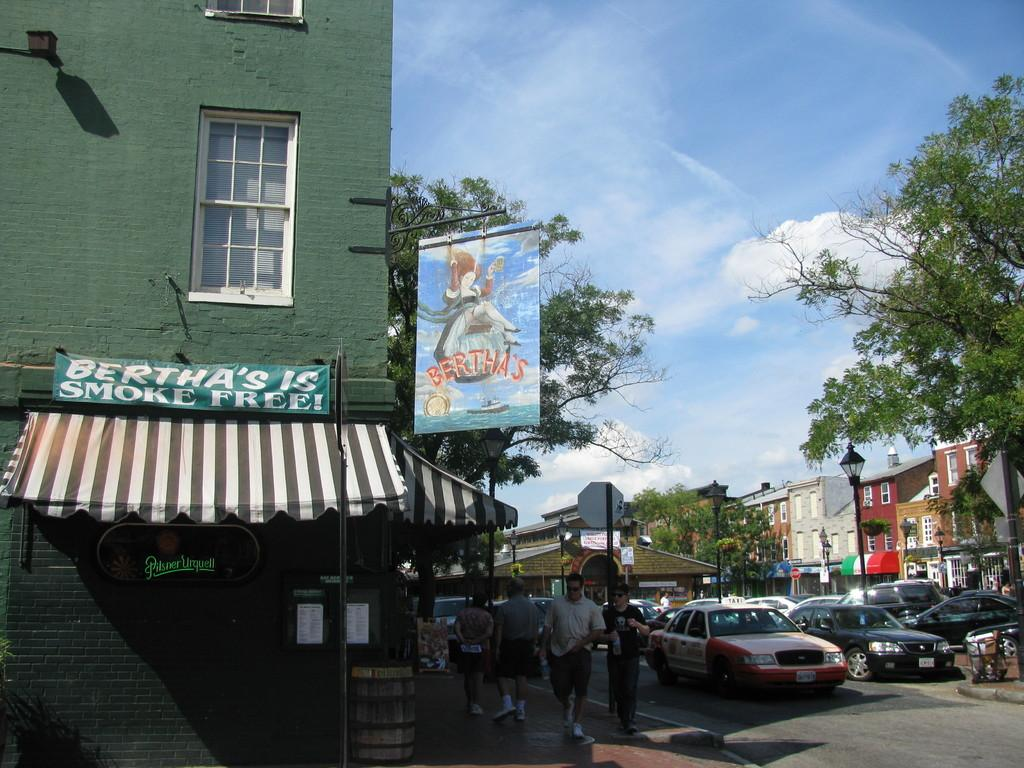<image>
Write a terse but informative summary of the picture. bertha's corner store claims to be smoke free 